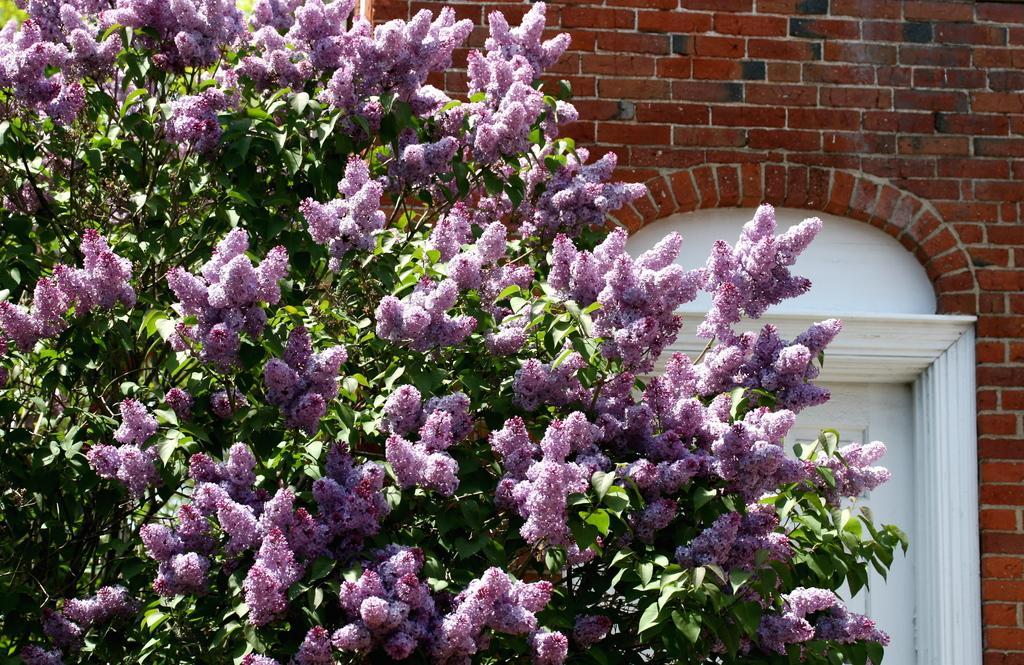Describe this image in one or two sentences. In this image we can see a tree to which there are some flowers and behind there is a brick wall to which there is a door. 